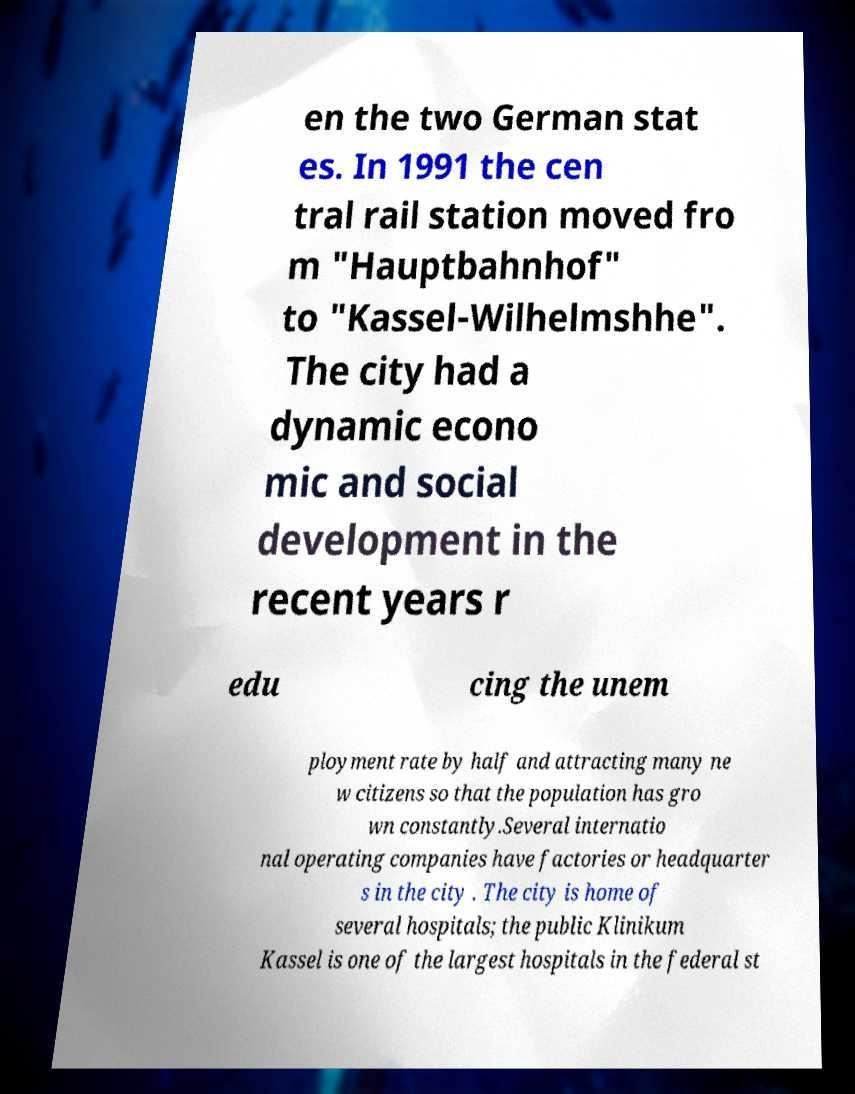Could you extract and type out the text from this image? en the two German stat es. In 1991 the cen tral rail station moved fro m "Hauptbahnhof" to "Kassel-Wilhelmshhe". The city had a dynamic econo mic and social development in the recent years r edu cing the unem ployment rate by half and attracting many ne w citizens so that the population has gro wn constantly.Several internatio nal operating companies have factories or headquarter s in the city . The city is home of several hospitals; the public Klinikum Kassel is one of the largest hospitals in the federal st 